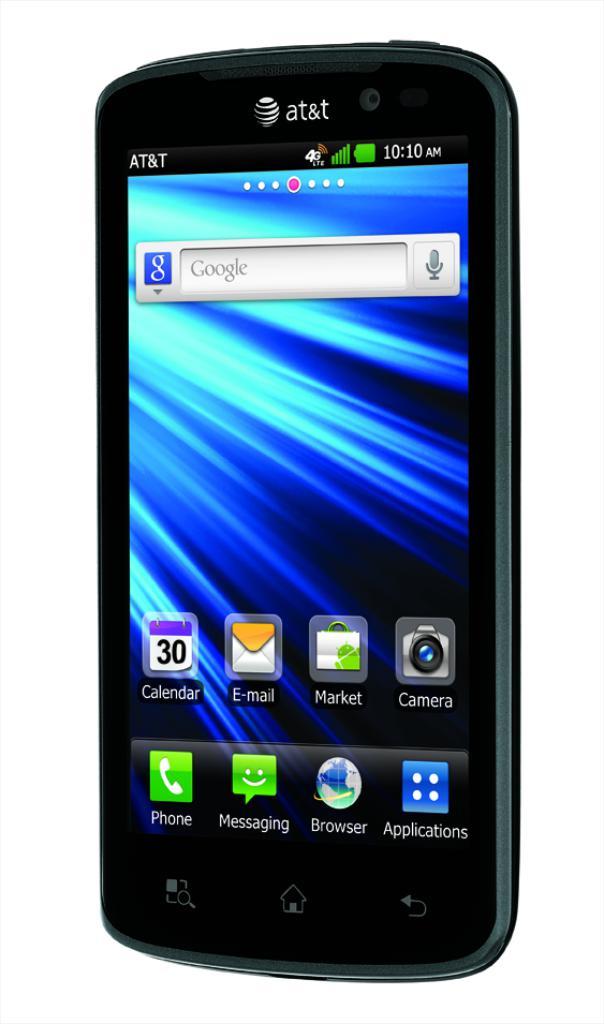Which network is this phone part of?
Your answer should be very brief. At&t. What is on the search bar at the top?
Your response must be concise. Google. 